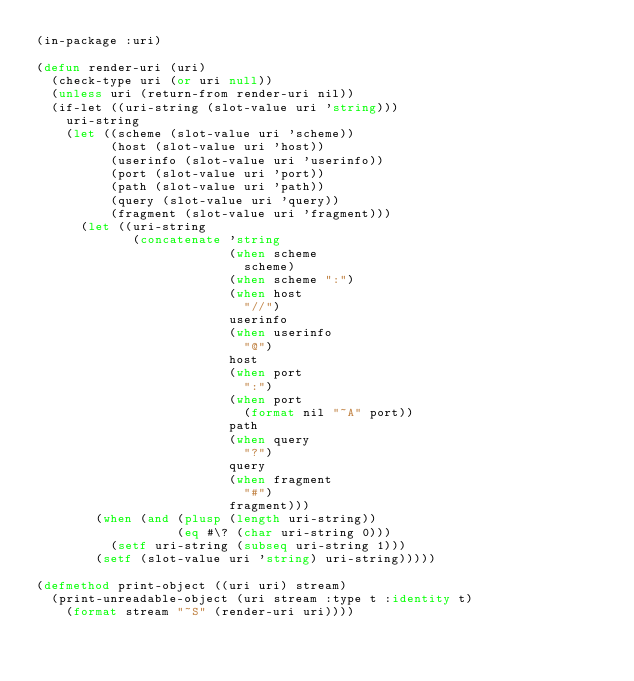Convert code to text. <code><loc_0><loc_0><loc_500><loc_500><_Lisp_>(in-package :uri)

(defun render-uri (uri)
  (check-type uri (or uri null))
  (unless uri (return-from render-uri nil))
  (if-let ((uri-string (slot-value uri 'string)))
    uri-string
    (let ((scheme (slot-value uri 'scheme))
          (host (slot-value uri 'host))
          (userinfo (slot-value uri 'userinfo))
          (port (slot-value uri 'port))
          (path (slot-value uri 'path))
          (query (slot-value uri 'query))
          (fragment (slot-value uri 'fragment)))
      (let ((uri-string
             (concatenate 'string
                          (when scheme
                            scheme)
                          (when scheme ":")
                          (when host
                            "//")
                          userinfo
                          (when userinfo
                            "@")
                          host
                          (when port
                            ":")
                          (when port
                            (format nil "~A" port))
                          path
                          (when query
                            "?")
                          query
                          (when fragment
                            "#")
                          fragment)))
        (when (and (plusp (length uri-string))
                   (eq #\? (char uri-string 0)))
          (setf uri-string (subseq uri-string 1)))
        (setf (slot-value uri 'string) uri-string)))))

(defmethod print-object ((uri uri) stream)
  (print-unreadable-object (uri stream :type t :identity t)
    (format stream "~S" (render-uri uri))))
</code> 